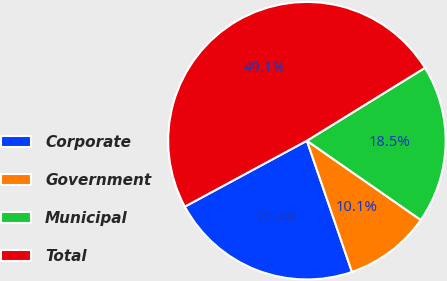Convert chart to OTSL. <chart><loc_0><loc_0><loc_500><loc_500><pie_chart><fcel>Corporate<fcel>Government<fcel>Municipal<fcel>Total<nl><fcel>22.38%<fcel>10.06%<fcel>18.48%<fcel>49.08%<nl></chart> 